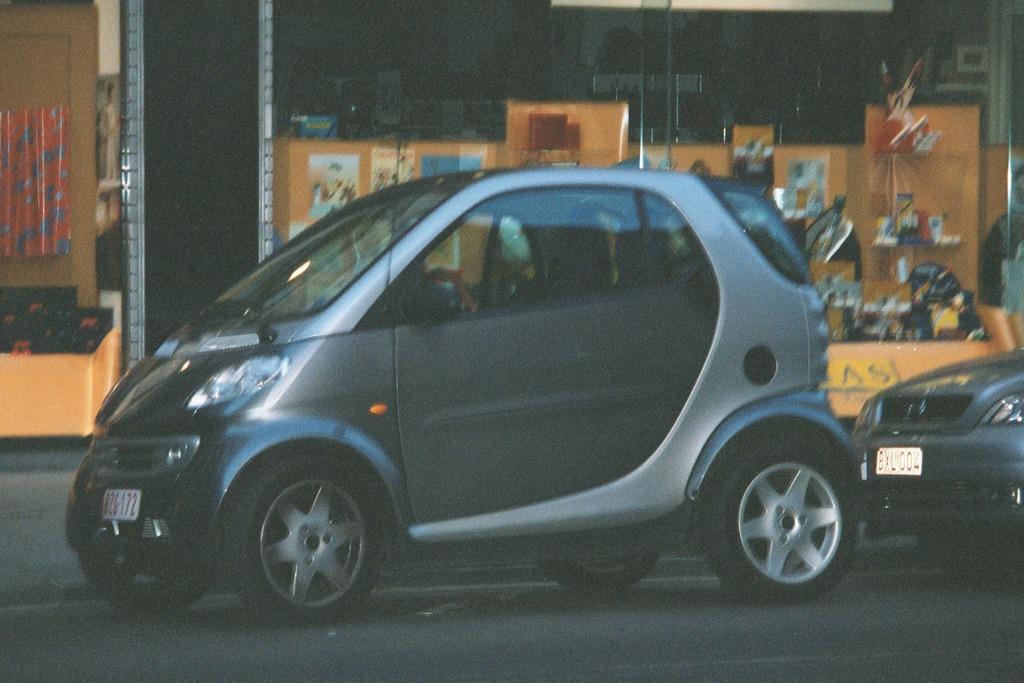Can you describe this image briefly? In the image there is a car moving on road followed by another car behind it and the background it seems to be a building with some stores in front of it. 